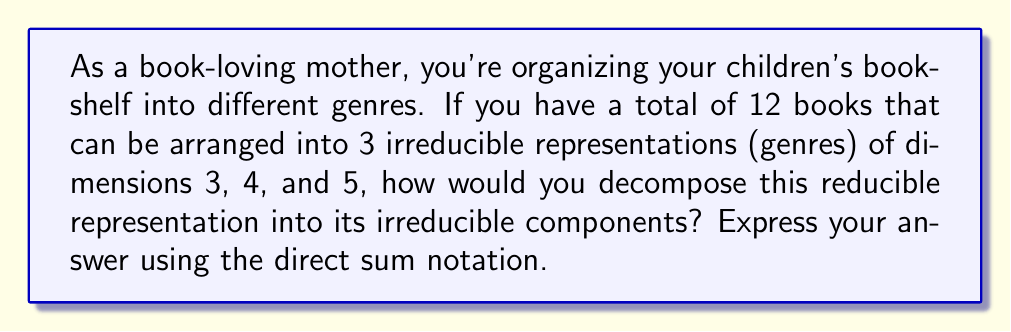Provide a solution to this math problem. Let's approach this step-by-step:

1) In Representation Theory, a reducible representation can be broken down into a direct sum of irreducible representations.

2) In this case, we have a total of 12 books, which represents the dimension of our reducible representation. Let's call this representation $V$.

3) We're told that this can be arranged into 3 irreducible representations (genres) with dimensions 3, 4, and 5. Let's call these $V_1$, $V_2$, and $V_3$ respectively.

4) To decompose $V$ into its irreducible components, we need to express it as a direct sum of $V_1$, $V_2$, and $V_3$.

5) The direct sum is denoted by the symbol $\oplus$.

6) Therefore, we can write:

   $$V = V_1 \oplus V_2 \oplus V_3$$

7) To verify, we can check that the dimensions add up correctly:

   $$\dim(V) = \dim(V_1) + \dim(V_2) + \dim(V_3) = 3 + 4 + 5 = 12$$

Thus, we have successfully decomposed the reducible representation into its irreducible components.
Answer: $$V = V_1 \oplus V_2 \oplus V_3$$ 